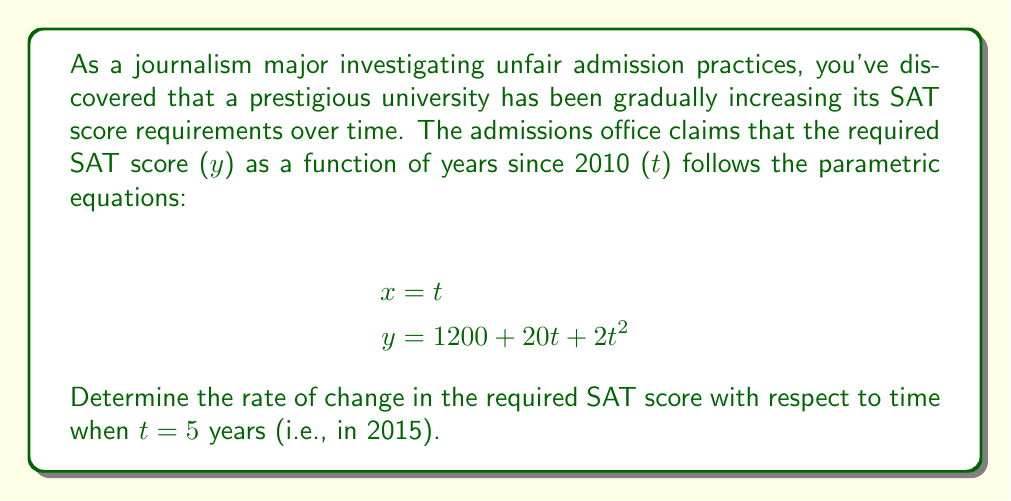Can you solve this math problem? To solve this problem, we need to find the derivative of y with respect to t, which represents the rate of change of the SAT score requirement over time. We can do this using the following steps:

1. First, we need to find $\frac{dy}{dt}$. Since y is already expressed as a function of t, we can directly differentiate it:

   $$\frac{dy}{dt} = \frac{d}{dt}(1200 + 20t + 2t^2) = 20 + 4t$$

2. Now that we have the rate of change function, we need to evaluate it at t = 5:

   $$\frac{dy}{dt}\bigg|_{t=5} = 20 + 4(5) = 20 + 20 = 40$$

This result means that in 2015 (5 years after 2010), the required SAT score was increasing at a rate of 40 points per year.

It's worth noting that this rate of change is not constant. The presence of the $t^2$ term in the original equation indicates that the rate of increase is itself increasing over time, which could be a concerning trend for fair admissions practices.
Answer: The rate of change in the required SAT score in 2015 was 40 points per year. 